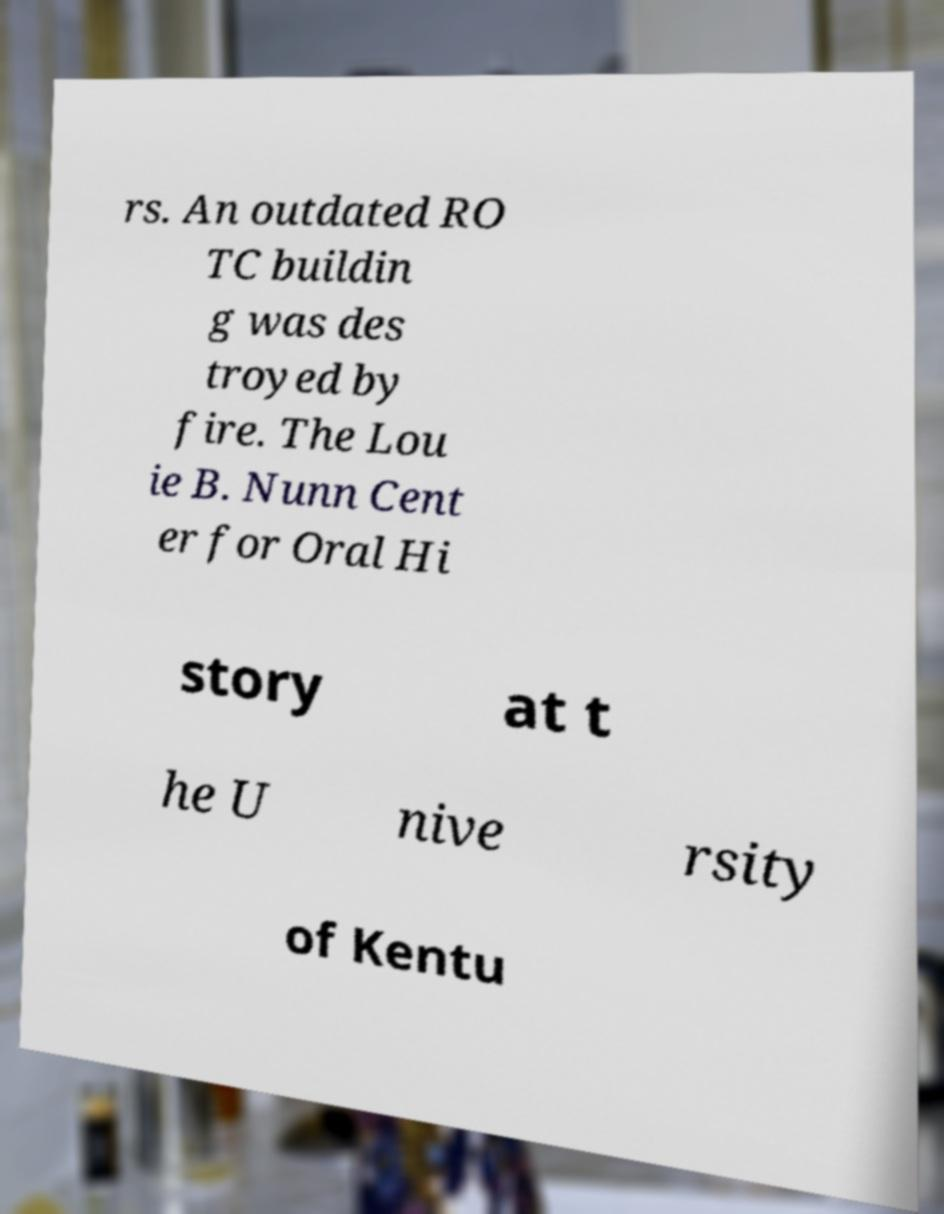Could you extract and type out the text from this image? rs. An outdated RO TC buildin g was des troyed by fire. The Lou ie B. Nunn Cent er for Oral Hi story at t he U nive rsity of Kentu 